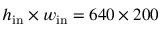<formula> <loc_0><loc_0><loc_500><loc_500>h _ { i n } \times w _ { i n } = 6 4 0 \times 2 0 0</formula> 